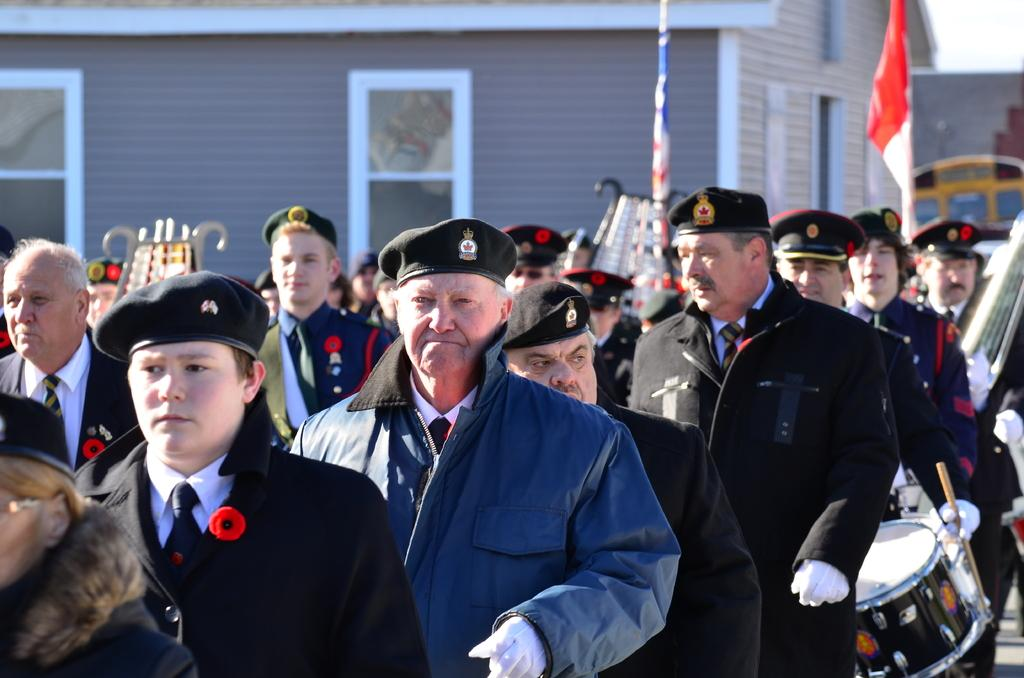How many people are in the image? There is a group of people in the image. Where are the people located in the image? The group of people is standing in the background. What can be seen in the background of the image besides the people? There is a flag, a building, and a window in the background of the image. What advertisement can be seen on the flag in the image? There is no advertisement present on the flag in the image; it is a plain flag. 